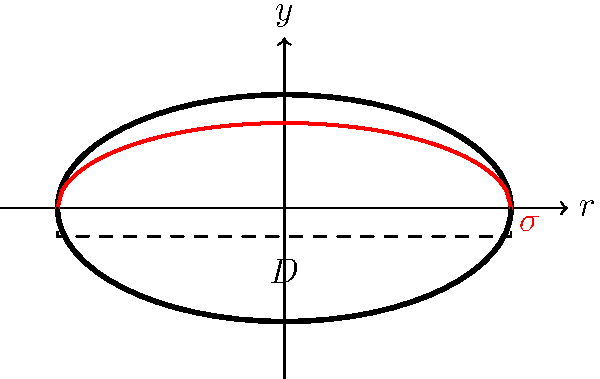Consider a submarine pressure hull with a circular cross-section of diameter $D$. The stress distribution $\sigma$ along the vertical axis can be approximated by the equation $\sigma = \sigma_{\text{max}} \sqrt{1 - (r/R)^2}$, where $r$ is the radial distance from the center, $R$ is the radius of the hull, and $\sigma_{\text{max}}$ is the maximum stress at the top and bottom of the hull. If the maximum allowable stress for the hull material is 300 MPa, what is the maximum depth the submarine can safely operate at, assuming a safety factor of 1.5 and seawater density of 1025 kg/m³? To solve this problem, we'll follow these steps:

1) First, we need to relate the maximum stress to the hydrostatic pressure:
   $\sigma_{\text{max}} = \frac{p \cdot R}{t}$
   where $p$ is the hydrostatic pressure, $R$ is the radius, and $t$ is the hull thickness.

2) The maximum allowable stress with the safety factor is:
   $\sigma_{\text{allowable}} = \frac{300 \text{ MPa}}{1.5} = 200 \text{ MPa}$

3) The hydrostatic pressure at depth $h$ is:
   $p = \rho g h$
   where $\rho$ is the seawater density and $g$ is the gravitational acceleration (9.81 m/s²).

4) Substituting this into the stress equation:
   $200 \text{ MPa} = \frac{\rho g h \cdot R}{t}$

5) Solving for $h$:
   $h = \frac{200 \text{ MPa} \cdot t}{\rho g R}$

6) The ratio $t/R$ is typically around 1/100 for submarine hulls. Using this:
   $h = \frac{200 \times 10^6 \text{ Pa} \cdot (1/100)}{1025 \text{ kg/m}^3 \cdot 9.81 \text{ m/s}^2}$

7) Calculating:
   $h \approx 198 \text{ m}$

Therefore, the maximum safe operating depth is approximately 198 meters.
Answer: 198 meters 